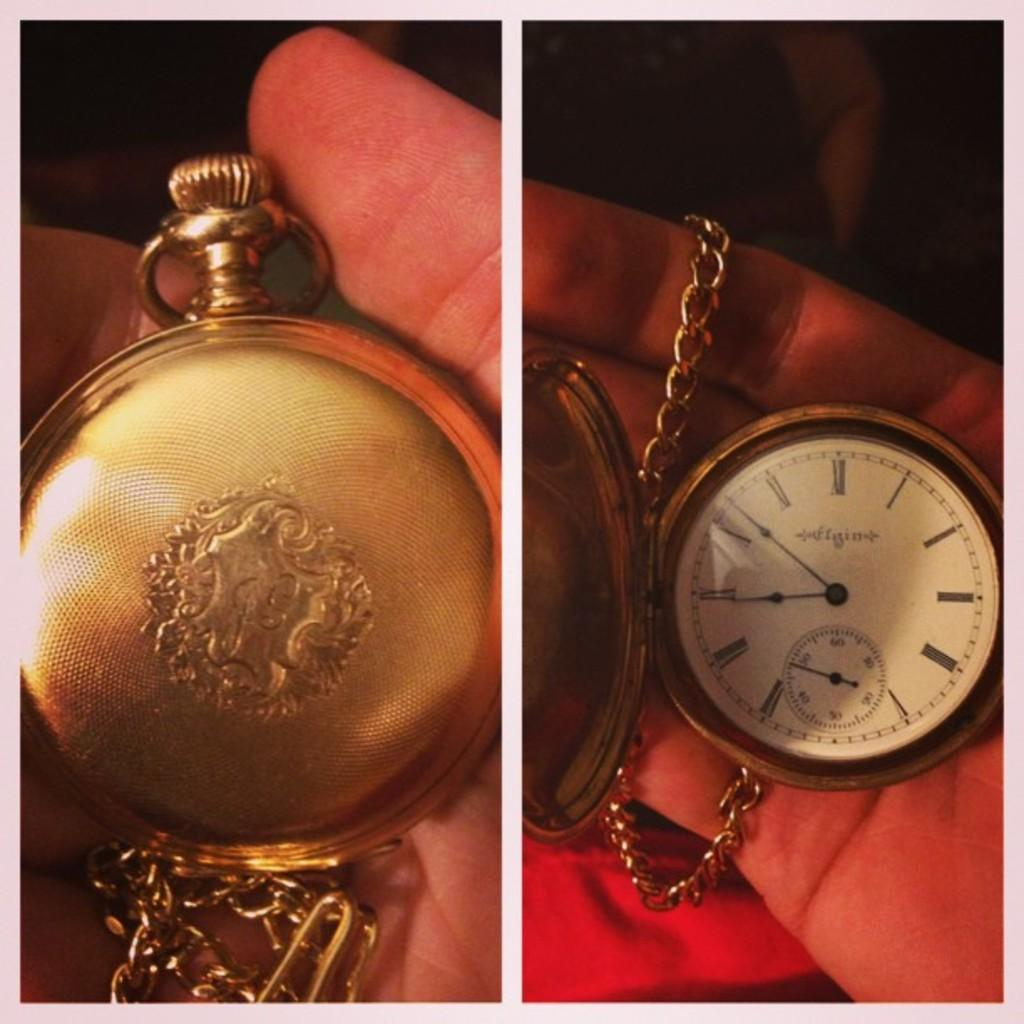<image>
Provide a brief description of the given image. A person is holding a pocket watch that shows the time as 7:47. 